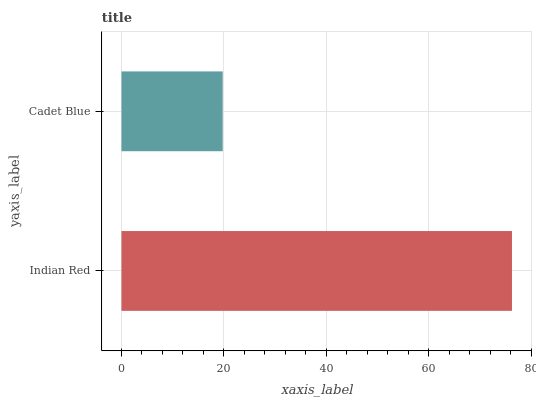Is Cadet Blue the minimum?
Answer yes or no. Yes. Is Indian Red the maximum?
Answer yes or no. Yes. Is Cadet Blue the maximum?
Answer yes or no. No. Is Indian Red greater than Cadet Blue?
Answer yes or no. Yes. Is Cadet Blue less than Indian Red?
Answer yes or no. Yes. Is Cadet Blue greater than Indian Red?
Answer yes or no. No. Is Indian Red less than Cadet Blue?
Answer yes or no. No. Is Indian Red the high median?
Answer yes or no. Yes. Is Cadet Blue the low median?
Answer yes or no. Yes. Is Cadet Blue the high median?
Answer yes or no. No. Is Indian Red the low median?
Answer yes or no. No. 